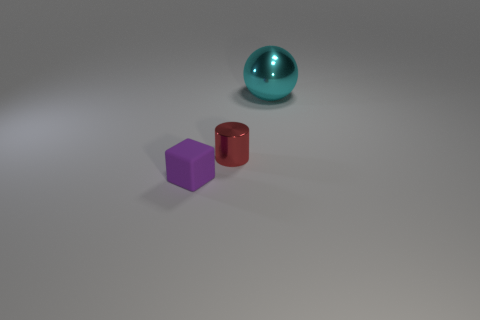Add 1 blue metal blocks. How many objects exist? 4 Subtract all balls. How many objects are left? 2 Add 1 blue rubber balls. How many blue rubber balls exist? 1 Subtract 0 purple balls. How many objects are left? 3 Subtract all large cyan objects. Subtract all tiny cyan matte balls. How many objects are left? 2 Add 2 tiny purple objects. How many tiny purple objects are left? 3 